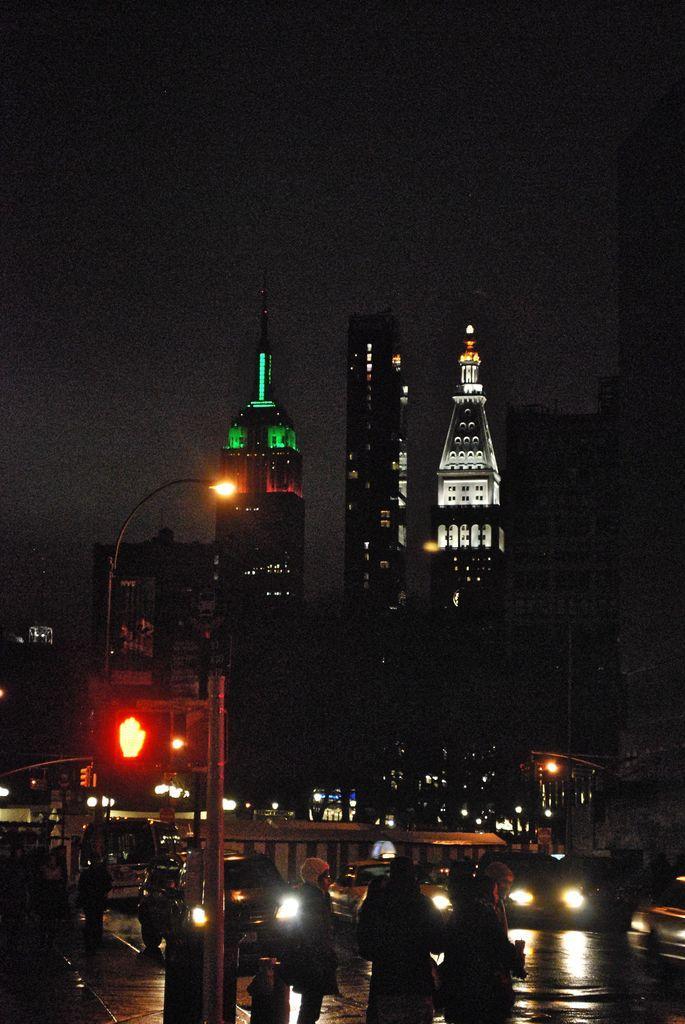Can you describe this image briefly? In this image I can see buildings, traffic light, street light and vehicles on the road. In the background I can see the sky. 